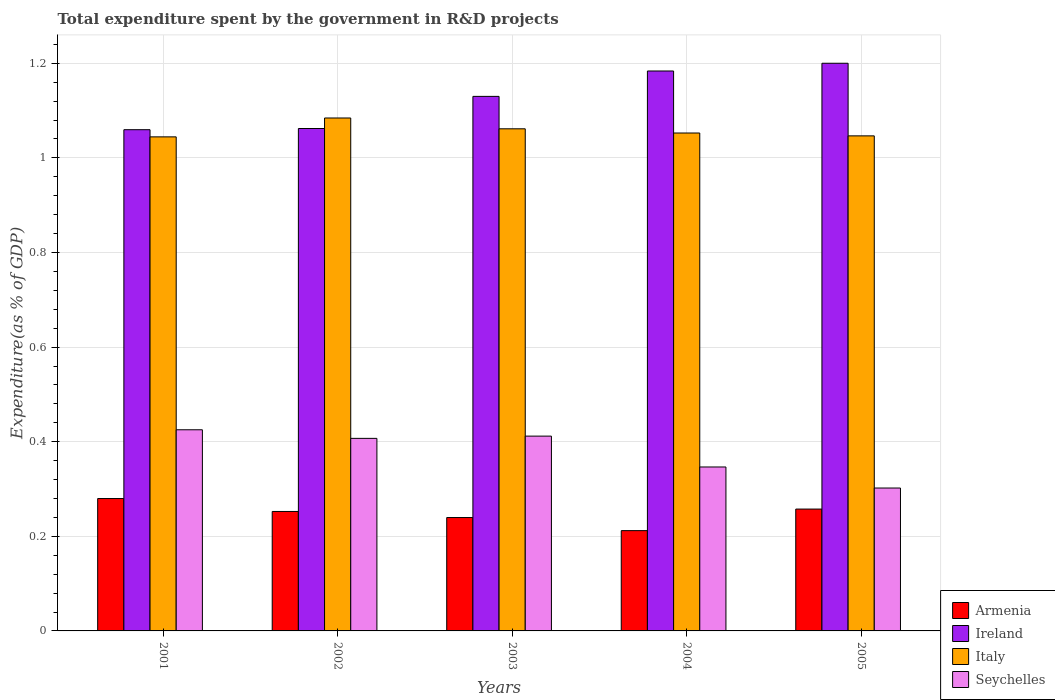How many different coloured bars are there?
Your answer should be very brief. 4. How many groups of bars are there?
Offer a very short reply. 5. Are the number of bars per tick equal to the number of legend labels?
Offer a terse response. Yes. Are the number of bars on each tick of the X-axis equal?
Ensure brevity in your answer.  Yes. How many bars are there on the 2nd tick from the right?
Your response must be concise. 4. What is the label of the 4th group of bars from the left?
Give a very brief answer. 2004. What is the total expenditure spent by the government in R&D projects in Italy in 2002?
Ensure brevity in your answer.  1.08. Across all years, what is the maximum total expenditure spent by the government in R&D projects in Armenia?
Ensure brevity in your answer.  0.28. Across all years, what is the minimum total expenditure spent by the government in R&D projects in Ireland?
Your answer should be compact. 1.06. In which year was the total expenditure spent by the government in R&D projects in Armenia minimum?
Keep it short and to the point. 2004. What is the total total expenditure spent by the government in R&D projects in Armenia in the graph?
Your answer should be compact. 1.24. What is the difference between the total expenditure spent by the government in R&D projects in Seychelles in 2004 and that in 2005?
Ensure brevity in your answer.  0.04. What is the difference between the total expenditure spent by the government in R&D projects in Ireland in 2005 and the total expenditure spent by the government in R&D projects in Seychelles in 2002?
Your answer should be compact. 0.79. What is the average total expenditure spent by the government in R&D projects in Seychelles per year?
Your response must be concise. 0.38. In the year 2001, what is the difference between the total expenditure spent by the government in R&D projects in Armenia and total expenditure spent by the government in R&D projects in Italy?
Provide a short and direct response. -0.76. In how many years, is the total expenditure spent by the government in R&D projects in Ireland greater than 0.16 %?
Your answer should be very brief. 5. What is the ratio of the total expenditure spent by the government in R&D projects in Italy in 2001 to that in 2005?
Ensure brevity in your answer.  1. Is the total expenditure spent by the government in R&D projects in Ireland in 2001 less than that in 2003?
Make the answer very short. Yes. Is the difference between the total expenditure spent by the government in R&D projects in Armenia in 2002 and 2004 greater than the difference between the total expenditure spent by the government in R&D projects in Italy in 2002 and 2004?
Make the answer very short. Yes. What is the difference between the highest and the second highest total expenditure spent by the government in R&D projects in Ireland?
Provide a succinct answer. 0.02. What is the difference between the highest and the lowest total expenditure spent by the government in R&D projects in Armenia?
Give a very brief answer. 0.07. What does the 1st bar from the left in 2001 represents?
Offer a very short reply. Armenia. What does the 4th bar from the right in 2005 represents?
Offer a very short reply. Armenia. How many bars are there?
Keep it short and to the point. 20. Are all the bars in the graph horizontal?
Your response must be concise. No. Are the values on the major ticks of Y-axis written in scientific E-notation?
Give a very brief answer. No. Does the graph contain any zero values?
Your answer should be compact. No. Does the graph contain grids?
Your answer should be very brief. Yes. How many legend labels are there?
Keep it short and to the point. 4. How are the legend labels stacked?
Ensure brevity in your answer.  Vertical. What is the title of the graph?
Provide a succinct answer. Total expenditure spent by the government in R&D projects. Does "Faeroe Islands" appear as one of the legend labels in the graph?
Your answer should be compact. No. What is the label or title of the Y-axis?
Your answer should be very brief. Expenditure(as % of GDP). What is the Expenditure(as % of GDP) of Armenia in 2001?
Give a very brief answer. 0.28. What is the Expenditure(as % of GDP) of Ireland in 2001?
Offer a terse response. 1.06. What is the Expenditure(as % of GDP) in Italy in 2001?
Keep it short and to the point. 1.04. What is the Expenditure(as % of GDP) in Seychelles in 2001?
Your response must be concise. 0.43. What is the Expenditure(as % of GDP) of Armenia in 2002?
Provide a succinct answer. 0.25. What is the Expenditure(as % of GDP) in Ireland in 2002?
Your answer should be very brief. 1.06. What is the Expenditure(as % of GDP) of Italy in 2002?
Give a very brief answer. 1.08. What is the Expenditure(as % of GDP) in Seychelles in 2002?
Make the answer very short. 0.41. What is the Expenditure(as % of GDP) of Armenia in 2003?
Ensure brevity in your answer.  0.24. What is the Expenditure(as % of GDP) of Ireland in 2003?
Your answer should be very brief. 1.13. What is the Expenditure(as % of GDP) of Italy in 2003?
Ensure brevity in your answer.  1.06. What is the Expenditure(as % of GDP) of Seychelles in 2003?
Make the answer very short. 0.41. What is the Expenditure(as % of GDP) of Armenia in 2004?
Provide a short and direct response. 0.21. What is the Expenditure(as % of GDP) in Ireland in 2004?
Give a very brief answer. 1.18. What is the Expenditure(as % of GDP) in Italy in 2004?
Give a very brief answer. 1.05. What is the Expenditure(as % of GDP) in Seychelles in 2004?
Make the answer very short. 0.35. What is the Expenditure(as % of GDP) of Armenia in 2005?
Your answer should be very brief. 0.26. What is the Expenditure(as % of GDP) in Ireland in 2005?
Provide a short and direct response. 1.2. What is the Expenditure(as % of GDP) of Italy in 2005?
Offer a very short reply. 1.05. What is the Expenditure(as % of GDP) of Seychelles in 2005?
Offer a terse response. 0.3. Across all years, what is the maximum Expenditure(as % of GDP) in Armenia?
Give a very brief answer. 0.28. Across all years, what is the maximum Expenditure(as % of GDP) of Ireland?
Your response must be concise. 1.2. Across all years, what is the maximum Expenditure(as % of GDP) in Italy?
Your response must be concise. 1.08. Across all years, what is the maximum Expenditure(as % of GDP) of Seychelles?
Provide a succinct answer. 0.43. Across all years, what is the minimum Expenditure(as % of GDP) of Armenia?
Offer a terse response. 0.21. Across all years, what is the minimum Expenditure(as % of GDP) in Ireland?
Your response must be concise. 1.06. Across all years, what is the minimum Expenditure(as % of GDP) of Italy?
Ensure brevity in your answer.  1.04. Across all years, what is the minimum Expenditure(as % of GDP) of Seychelles?
Your answer should be compact. 0.3. What is the total Expenditure(as % of GDP) in Armenia in the graph?
Your answer should be very brief. 1.24. What is the total Expenditure(as % of GDP) of Ireland in the graph?
Offer a terse response. 5.64. What is the total Expenditure(as % of GDP) of Italy in the graph?
Offer a very short reply. 5.29. What is the total Expenditure(as % of GDP) of Seychelles in the graph?
Give a very brief answer. 1.89. What is the difference between the Expenditure(as % of GDP) in Armenia in 2001 and that in 2002?
Your answer should be compact. 0.03. What is the difference between the Expenditure(as % of GDP) of Ireland in 2001 and that in 2002?
Provide a short and direct response. -0. What is the difference between the Expenditure(as % of GDP) in Italy in 2001 and that in 2002?
Provide a succinct answer. -0.04. What is the difference between the Expenditure(as % of GDP) of Seychelles in 2001 and that in 2002?
Provide a short and direct response. 0.02. What is the difference between the Expenditure(as % of GDP) in Armenia in 2001 and that in 2003?
Provide a succinct answer. 0.04. What is the difference between the Expenditure(as % of GDP) in Ireland in 2001 and that in 2003?
Keep it short and to the point. -0.07. What is the difference between the Expenditure(as % of GDP) of Italy in 2001 and that in 2003?
Make the answer very short. -0.02. What is the difference between the Expenditure(as % of GDP) of Seychelles in 2001 and that in 2003?
Provide a succinct answer. 0.01. What is the difference between the Expenditure(as % of GDP) in Armenia in 2001 and that in 2004?
Provide a short and direct response. 0.07. What is the difference between the Expenditure(as % of GDP) of Ireland in 2001 and that in 2004?
Make the answer very short. -0.12. What is the difference between the Expenditure(as % of GDP) in Italy in 2001 and that in 2004?
Make the answer very short. -0.01. What is the difference between the Expenditure(as % of GDP) in Seychelles in 2001 and that in 2004?
Your response must be concise. 0.08. What is the difference between the Expenditure(as % of GDP) in Armenia in 2001 and that in 2005?
Your answer should be compact. 0.02. What is the difference between the Expenditure(as % of GDP) of Ireland in 2001 and that in 2005?
Your response must be concise. -0.14. What is the difference between the Expenditure(as % of GDP) of Italy in 2001 and that in 2005?
Your answer should be compact. -0. What is the difference between the Expenditure(as % of GDP) in Seychelles in 2001 and that in 2005?
Your answer should be very brief. 0.12. What is the difference between the Expenditure(as % of GDP) of Armenia in 2002 and that in 2003?
Ensure brevity in your answer.  0.01. What is the difference between the Expenditure(as % of GDP) in Ireland in 2002 and that in 2003?
Make the answer very short. -0.07. What is the difference between the Expenditure(as % of GDP) in Italy in 2002 and that in 2003?
Your answer should be very brief. 0.02. What is the difference between the Expenditure(as % of GDP) of Seychelles in 2002 and that in 2003?
Provide a short and direct response. -0. What is the difference between the Expenditure(as % of GDP) of Armenia in 2002 and that in 2004?
Your response must be concise. 0.04. What is the difference between the Expenditure(as % of GDP) in Ireland in 2002 and that in 2004?
Your answer should be very brief. -0.12. What is the difference between the Expenditure(as % of GDP) of Italy in 2002 and that in 2004?
Your response must be concise. 0.03. What is the difference between the Expenditure(as % of GDP) of Seychelles in 2002 and that in 2004?
Provide a short and direct response. 0.06. What is the difference between the Expenditure(as % of GDP) in Armenia in 2002 and that in 2005?
Your answer should be very brief. -0.01. What is the difference between the Expenditure(as % of GDP) of Ireland in 2002 and that in 2005?
Offer a terse response. -0.14. What is the difference between the Expenditure(as % of GDP) in Italy in 2002 and that in 2005?
Your response must be concise. 0.04. What is the difference between the Expenditure(as % of GDP) of Seychelles in 2002 and that in 2005?
Provide a succinct answer. 0.1. What is the difference between the Expenditure(as % of GDP) of Armenia in 2003 and that in 2004?
Ensure brevity in your answer.  0.03. What is the difference between the Expenditure(as % of GDP) in Ireland in 2003 and that in 2004?
Your answer should be very brief. -0.05. What is the difference between the Expenditure(as % of GDP) of Italy in 2003 and that in 2004?
Provide a short and direct response. 0.01. What is the difference between the Expenditure(as % of GDP) of Seychelles in 2003 and that in 2004?
Offer a terse response. 0.07. What is the difference between the Expenditure(as % of GDP) of Armenia in 2003 and that in 2005?
Give a very brief answer. -0.02. What is the difference between the Expenditure(as % of GDP) in Ireland in 2003 and that in 2005?
Offer a terse response. -0.07. What is the difference between the Expenditure(as % of GDP) in Italy in 2003 and that in 2005?
Your answer should be compact. 0.01. What is the difference between the Expenditure(as % of GDP) of Seychelles in 2003 and that in 2005?
Make the answer very short. 0.11. What is the difference between the Expenditure(as % of GDP) of Armenia in 2004 and that in 2005?
Make the answer very short. -0.05. What is the difference between the Expenditure(as % of GDP) in Ireland in 2004 and that in 2005?
Offer a very short reply. -0.02. What is the difference between the Expenditure(as % of GDP) of Italy in 2004 and that in 2005?
Your answer should be compact. 0.01. What is the difference between the Expenditure(as % of GDP) in Seychelles in 2004 and that in 2005?
Offer a terse response. 0.04. What is the difference between the Expenditure(as % of GDP) in Armenia in 2001 and the Expenditure(as % of GDP) in Ireland in 2002?
Your response must be concise. -0.78. What is the difference between the Expenditure(as % of GDP) of Armenia in 2001 and the Expenditure(as % of GDP) of Italy in 2002?
Offer a terse response. -0.8. What is the difference between the Expenditure(as % of GDP) of Armenia in 2001 and the Expenditure(as % of GDP) of Seychelles in 2002?
Keep it short and to the point. -0.13. What is the difference between the Expenditure(as % of GDP) in Ireland in 2001 and the Expenditure(as % of GDP) in Italy in 2002?
Give a very brief answer. -0.02. What is the difference between the Expenditure(as % of GDP) of Ireland in 2001 and the Expenditure(as % of GDP) of Seychelles in 2002?
Ensure brevity in your answer.  0.65. What is the difference between the Expenditure(as % of GDP) of Italy in 2001 and the Expenditure(as % of GDP) of Seychelles in 2002?
Your response must be concise. 0.64. What is the difference between the Expenditure(as % of GDP) of Armenia in 2001 and the Expenditure(as % of GDP) of Ireland in 2003?
Keep it short and to the point. -0.85. What is the difference between the Expenditure(as % of GDP) in Armenia in 2001 and the Expenditure(as % of GDP) in Italy in 2003?
Offer a very short reply. -0.78. What is the difference between the Expenditure(as % of GDP) of Armenia in 2001 and the Expenditure(as % of GDP) of Seychelles in 2003?
Keep it short and to the point. -0.13. What is the difference between the Expenditure(as % of GDP) in Ireland in 2001 and the Expenditure(as % of GDP) in Italy in 2003?
Make the answer very short. -0. What is the difference between the Expenditure(as % of GDP) of Ireland in 2001 and the Expenditure(as % of GDP) of Seychelles in 2003?
Ensure brevity in your answer.  0.65. What is the difference between the Expenditure(as % of GDP) in Italy in 2001 and the Expenditure(as % of GDP) in Seychelles in 2003?
Ensure brevity in your answer.  0.63. What is the difference between the Expenditure(as % of GDP) of Armenia in 2001 and the Expenditure(as % of GDP) of Ireland in 2004?
Ensure brevity in your answer.  -0.9. What is the difference between the Expenditure(as % of GDP) in Armenia in 2001 and the Expenditure(as % of GDP) in Italy in 2004?
Keep it short and to the point. -0.77. What is the difference between the Expenditure(as % of GDP) in Armenia in 2001 and the Expenditure(as % of GDP) in Seychelles in 2004?
Provide a succinct answer. -0.07. What is the difference between the Expenditure(as % of GDP) of Ireland in 2001 and the Expenditure(as % of GDP) of Italy in 2004?
Give a very brief answer. 0.01. What is the difference between the Expenditure(as % of GDP) of Ireland in 2001 and the Expenditure(as % of GDP) of Seychelles in 2004?
Your answer should be compact. 0.71. What is the difference between the Expenditure(as % of GDP) of Italy in 2001 and the Expenditure(as % of GDP) of Seychelles in 2004?
Your response must be concise. 0.7. What is the difference between the Expenditure(as % of GDP) of Armenia in 2001 and the Expenditure(as % of GDP) of Ireland in 2005?
Keep it short and to the point. -0.92. What is the difference between the Expenditure(as % of GDP) in Armenia in 2001 and the Expenditure(as % of GDP) in Italy in 2005?
Make the answer very short. -0.77. What is the difference between the Expenditure(as % of GDP) of Armenia in 2001 and the Expenditure(as % of GDP) of Seychelles in 2005?
Offer a very short reply. -0.02. What is the difference between the Expenditure(as % of GDP) of Ireland in 2001 and the Expenditure(as % of GDP) of Italy in 2005?
Offer a terse response. 0.01. What is the difference between the Expenditure(as % of GDP) in Ireland in 2001 and the Expenditure(as % of GDP) in Seychelles in 2005?
Your answer should be very brief. 0.76. What is the difference between the Expenditure(as % of GDP) of Italy in 2001 and the Expenditure(as % of GDP) of Seychelles in 2005?
Keep it short and to the point. 0.74. What is the difference between the Expenditure(as % of GDP) in Armenia in 2002 and the Expenditure(as % of GDP) in Ireland in 2003?
Give a very brief answer. -0.88. What is the difference between the Expenditure(as % of GDP) of Armenia in 2002 and the Expenditure(as % of GDP) of Italy in 2003?
Your answer should be compact. -0.81. What is the difference between the Expenditure(as % of GDP) in Armenia in 2002 and the Expenditure(as % of GDP) in Seychelles in 2003?
Give a very brief answer. -0.16. What is the difference between the Expenditure(as % of GDP) of Ireland in 2002 and the Expenditure(as % of GDP) of Italy in 2003?
Your answer should be very brief. 0. What is the difference between the Expenditure(as % of GDP) in Ireland in 2002 and the Expenditure(as % of GDP) in Seychelles in 2003?
Ensure brevity in your answer.  0.65. What is the difference between the Expenditure(as % of GDP) of Italy in 2002 and the Expenditure(as % of GDP) of Seychelles in 2003?
Give a very brief answer. 0.67. What is the difference between the Expenditure(as % of GDP) of Armenia in 2002 and the Expenditure(as % of GDP) of Ireland in 2004?
Give a very brief answer. -0.93. What is the difference between the Expenditure(as % of GDP) of Armenia in 2002 and the Expenditure(as % of GDP) of Italy in 2004?
Make the answer very short. -0.8. What is the difference between the Expenditure(as % of GDP) in Armenia in 2002 and the Expenditure(as % of GDP) in Seychelles in 2004?
Ensure brevity in your answer.  -0.09. What is the difference between the Expenditure(as % of GDP) of Ireland in 2002 and the Expenditure(as % of GDP) of Italy in 2004?
Make the answer very short. 0.01. What is the difference between the Expenditure(as % of GDP) in Ireland in 2002 and the Expenditure(as % of GDP) in Seychelles in 2004?
Provide a short and direct response. 0.72. What is the difference between the Expenditure(as % of GDP) in Italy in 2002 and the Expenditure(as % of GDP) in Seychelles in 2004?
Keep it short and to the point. 0.74. What is the difference between the Expenditure(as % of GDP) of Armenia in 2002 and the Expenditure(as % of GDP) of Ireland in 2005?
Provide a succinct answer. -0.95. What is the difference between the Expenditure(as % of GDP) of Armenia in 2002 and the Expenditure(as % of GDP) of Italy in 2005?
Provide a short and direct response. -0.79. What is the difference between the Expenditure(as % of GDP) of Armenia in 2002 and the Expenditure(as % of GDP) of Seychelles in 2005?
Your answer should be very brief. -0.05. What is the difference between the Expenditure(as % of GDP) in Ireland in 2002 and the Expenditure(as % of GDP) in Italy in 2005?
Your response must be concise. 0.02. What is the difference between the Expenditure(as % of GDP) of Ireland in 2002 and the Expenditure(as % of GDP) of Seychelles in 2005?
Offer a terse response. 0.76. What is the difference between the Expenditure(as % of GDP) of Italy in 2002 and the Expenditure(as % of GDP) of Seychelles in 2005?
Make the answer very short. 0.78. What is the difference between the Expenditure(as % of GDP) of Armenia in 2003 and the Expenditure(as % of GDP) of Ireland in 2004?
Ensure brevity in your answer.  -0.94. What is the difference between the Expenditure(as % of GDP) in Armenia in 2003 and the Expenditure(as % of GDP) in Italy in 2004?
Ensure brevity in your answer.  -0.81. What is the difference between the Expenditure(as % of GDP) in Armenia in 2003 and the Expenditure(as % of GDP) in Seychelles in 2004?
Your answer should be compact. -0.11. What is the difference between the Expenditure(as % of GDP) of Ireland in 2003 and the Expenditure(as % of GDP) of Italy in 2004?
Offer a terse response. 0.08. What is the difference between the Expenditure(as % of GDP) of Ireland in 2003 and the Expenditure(as % of GDP) of Seychelles in 2004?
Ensure brevity in your answer.  0.78. What is the difference between the Expenditure(as % of GDP) in Italy in 2003 and the Expenditure(as % of GDP) in Seychelles in 2004?
Your answer should be compact. 0.71. What is the difference between the Expenditure(as % of GDP) of Armenia in 2003 and the Expenditure(as % of GDP) of Ireland in 2005?
Your answer should be very brief. -0.96. What is the difference between the Expenditure(as % of GDP) of Armenia in 2003 and the Expenditure(as % of GDP) of Italy in 2005?
Offer a very short reply. -0.81. What is the difference between the Expenditure(as % of GDP) in Armenia in 2003 and the Expenditure(as % of GDP) in Seychelles in 2005?
Make the answer very short. -0.06. What is the difference between the Expenditure(as % of GDP) in Ireland in 2003 and the Expenditure(as % of GDP) in Italy in 2005?
Your answer should be compact. 0.08. What is the difference between the Expenditure(as % of GDP) in Ireland in 2003 and the Expenditure(as % of GDP) in Seychelles in 2005?
Offer a very short reply. 0.83. What is the difference between the Expenditure(as % of GDP) in Italy in 2003 and the Expenditure(as % of GDP) in Seychelles in 2005?
Your answer should be very brief. 0.76. What is the difference between the Expenditure(as % of GDP) in Armenia in 2004 and the Expenditure(as % of GDP) in Ireland in 2005?
Make the answer very short. -0.99. What is the difference between the Expenditure(as % of GDP) in Armenia in 2004 and the Expenditure(as % of GDP) in Italy in 2005?
Make the answer very short. -0.83. What is the difference between the Expenditure(as % of GDP) in Armenia in 2004 and the Expenditure(as % of GDP) in Seychelles in 2005?
Provide a short and direct response. -0.09. What is the difference between the Expenditure(as % of GDP) of Ireland in 2004 and the Expenditure(as % of GDP) of Italy in 2005?
Your answer should be very brief. 0.14. What is the difference between the Expenditure(as % of GDP) of Ireland in 2004 and the Expenditure(as % of GDP) of Seychelles in 2005?
Your answer should be very brief. 0.88. What is the difference between the Expenditure(as % of GDP) in Italy in 2004 and the Expenditure(as % of GDP) in Seychelles in 2005?
Give a very brief answer. 0.75. What is the average Expenditure(as % of GDP) of Armenia per year?
Give a very brief answer. 0.25. What is the average Expenditure(as % of GDP) of Ireland per year?
Your response must be concise. 1.13. What is the average Expenditure(as % of GDP) of Italy per year?
Your response must be concise. 1.06. What is the average Expenditure(as % of GDP) of Seychelles per year?
Your answer should be very brief. 0.38. In the year 2001, what is the difference between the Expenditure(as % of GDP) of Armenia and Expenditure(as % of GDP) of Ireland?
Keep it short and to the point. -0.78. In the year 2001, what is the difference between the Expenditure(as % of GDP) of Armenia and Expenditure(as % of GDP) of Italy?
Provide a succinct answer. -0.76. In the year 2001, what is the difference between the Expenditure(as % of GDP) of Armenia and Expenditure(as % of GDP) of Seychelles?
Offer a terse response. -0.15. In the year 2001, what is the difference between the Expenditure(as % of GDP) in Ireland and Expenditure(as % of GDP) in Italy?
Provide a succinct answer. 0.02. In the year 2001, what is the difference between the Expenditure(as % of GDP) of Ireland and Expenditure(as % of GDP) of Seychelles?
Provide a succinct answer. 0.63. In the year 2001, what is the difference between the Expenditure(as % of GDP) of Italy and Expenditure(as % of GDP) of Seychelles?
Make the answer very short. 0.62. In the year 2002, what is the difference between the Expenditure(as % of GDP) in Armenia and Expenditure(as % of GDP) in Ireland?
Make the answer very short. -0.81. In the year 2002, what is the difference between the Expenditure(as % of GDP) in Armenia and Expenditure(as % of GDP) in Italy?
Offer a very short reply. -0.83. In the year 2002, what is the difference between the Expenditure(as % of GDP) of Armenia and Expenditure(as % of GDP) of Seychelles?
Give a very brief answer. -0.15. In the year 2002, what is the difference between the Expenditure(as % of GDP) in Ireland and Expenditure(as % of GDP) in Italy?
Your answer should be very brief. -0.02. In the year 2002, what is the difference between the Expenditure(as % of GDP) of Ireland and Expenditure(as % of GDP) of Seychelles?
Make the answer very short. 0.66. In the year 2002, what is the difference between the Expenditure(as % of GDP) in Italy and Expenditure(as % of GDP) in Seychelles?
Make the answer very short. 0.68. In the year 2003, what is the difference between the Expenditure(as % of GDP) in Armenia and Expenditure(as % of GDP) in Ireland?
Offer a terse response. -0.89. In the year 2003, what is the difference between the Expenditure(as % of GDP) in Armenia and Expenditure(as % of GDP) in Italy?
Your answer should be compact. -0.82. In the year 2003, what is the difference between the Expenditure(as % of GDP) of Armenia and Expenditure(as % of GDP) of Seychelles?
Give a very brief answer. -0.17. In the year 2003, what is the difference between the Expenditure(as % of GDP) of Ireland and Expenditure(as % of GDP) of Italy?
Your answer should be compact. 0.07. In the year 2003, what is the difference between the Expenditure(as % of GDP) in Ireland and Expenditure(as % of GDP) in Seychelles?
Offer a terse response. 0.72. In the year 2003, what is the difference between the Expenditure(as % of GDP) of Italy and Expenditure(as % of GDP) of Seychelles?
Offer a very short reply. 0.65. In the year 2004, what is the difference between the Expenditure(as % of GDP) in Armenia and Expenditure(as % of GDP) in Ireland?
Offer a very short reply. -0.97. In the year 2004, what is the difference between the Expenditure(as % of GDP) of Armenia and Expenditure(as % of GDP) of Italy?
Offer a terse response. -0.84. In the year 2004, what is the difference between the Expenditure(as % of GDP) of Armenia and Expenditure(as % of GDP) of Seychelles?
Provide a short and direct response. -0.13. In the year 2004, what is the difference between the Expenditure(as % of GDP) of Ireland and Expenditure(as % of GDP) of Italy?
Provide a short and direct response. 0.13. In the year 2004, what is the difference between the Expenditure(as % of GDP) in Ireland and Expenditure(as % of GDP) in Seychelles?
Ensure brevity in your answer.  0.84. In the year 2004, what is the difference between the Expenditure(as % of GDP) of Italy and Expenditure(as % of GDP) of Seychelles?
Your answer should be very brief. 0.71. In the year 2005, what is the difference between the Expenditure(as % of GDP) in Armenia and Expenditure(as % of GDP) in Ireland?
Your answer should be compact. -0.94. In the year 2005, what is the difference between the Expenditure(as % of GDP) in Armenia and Expenditure(as % of GDP) in Italy?
Your answer should be very brief. -0.79. In the year 2005, what is the difference between the Expenditure(as % of GDP) of Armenia and Expenditure(as % of GDP) of Seychelles?
Make the answer very short. -0.04. In the year 2005, what is the difference between the Expenditure(as % of GDP) of Ireland and Expenditure(as % of GDP) of Italy?
Offer a very short reply. 0.15. In the year 2005, what is the difference between the Expenditure(as % of GDP) of Ireland and Expenditure(as % of GDP) of Seychelles?
Your answer should be very brief. 0.9. In the year 2005, what is the difference between the Expenditure(as % of GDP) of Italy and Expenditure(as % of GDP) of Seychelles?
Your response must be concise. 0.74. What is the ratio of the Expenditure(as % of GDP) in Armenia in 2001 to that in 2002?
Your response must be concise. 1.11. What is the ratio of the Expenditure(as % of GDP) in Italy in 2001 to that in 2002?
Ensure brevity in your answer.  0.96. What is the ratio of the Expenditure(as % of GDP) in Seychelles in 2001 to that in 2002?
Keep it short and to the point. 1.04. What is the ratio of the Expenditure(as % of GDP) in Armenia in 2001 to that in 2003?
Give a very brief answer. 1.17. What is the ratio of the Expenditure(as % of GDP) of Ireland in 2001 to that in 2003?
Your answer should be compact. 0.94. What is the ratio of the Expenditure(as % of GDP) of Italy in 2001 to that in 2003?
Your response must be concise. 0.98. What is the ratio of the Expenditure(as % of GDP) of Seychelles in 2001 to that in 2003?
Your answer should be very brief. 1.03. What is the ratio of the Expenditure(as % of GDP) of Armenia in 2001 to that in 2004?
Ensure brevity in your answer.  1.32. What is the ratio of the Expenditure(as % of GDP) in Ireland in 2001 to that in 2004?
Ensure brevity in your answer.  0.9. What is the ratio of the Expenditure(as % of GDP) of Seychelles in 2001 to that in 2004?
Ensure brevity in your answer.  1.23. What is the ratio of the Expenditure(as % of GDP) in Armenia in 2001 to that in 2005?
Keep it short and to the point. 1.09. What is the ratio of the Expenditure(as % of GDP) in Ireland in 2001 to that in 2005?
Make the answer very short. 0.88. What is the ratio of the Expenditure(as % of GDP) of Seychelles in 2001 to that in 2005?
Offer a terse response. 1.41. What is the ratio of the Expenditure(as % of GDP) of Armenia in 2002 to that in 2003?
Keep it short and to the point. 1.05. What is the ratio of the Expenditure(as % of GDP) of Ireland in 2002 to that in 2003?
Your answer should be compact. 0.94. What is the ratio of the Expenditure(as % of GDP) of Italy in 2002 to that in 2003?
Your answer should be compact. 1.02. What is the ratio of the Expenditure(as % of GDP) in Seychelles in 2002 to that in 2003?
Offer a terse response. 0.99. What is the ratio of the Expenditure(as % of GDP) in Armenia in 2002 to that in 2004?
Your answer should be very brief. 1.19. What is the ratio of the Expenditure(as % of GDP) in Ireland in 2002 to that in 2004?
Ensure brevity in your answer.  0.9. What is the ratio of the Expenditure(as % of GDP) in Italy in 2002 to that in 2004?
Make the answer very short. 1.03. What is the ratio of the Expenditure(as % of GDP) of Seychelles in 2002 to that in 2004?
Offer a terse response. 1.17. What is the ratio of the Expenditure(as % of GDP) in Armenia in 2002 to that in 2005?
Offer a terse response. 0.98. What is the ratio of the Expenditure(as % of GDP) of Ireland in 2002 to that in 2005?
Make the answer very short. 0.89. What is the ratio of the Expenditure(as % of GDP) of Italy in 2002 to that in 2005?
Your answer should be very brief. 1.04. What is the ratio of the Expenditure(as % of GDP) in Seychelles in 2002 to that in 2005?
Provide a succinct answer. 1.35. What is the ratio of the Expenditure(as % of GDP) of Armenia in 2003 to that in 2004?
Your answer should be compact. 1.13. What is the ratio of the Expenditure(as % of GDP) of Ireland in 2003 to that in 2004?
Ensure brevity in your answer.  0.95. What is the ratio of the Expenditure(as % of GDP) in Italy in 2003 to that in 2004?
Your response must be concise. 1.01. What is the ratio of the Expenditure(as % of GDP) of Seychelles in 2003 to that in 2004?
Provide a succinct answer. 1.19. What is the ratio of the Expenditure(as % of GDP) in Armenia in 2003 to that in 2005?
Offer a very short reply. 0.93. What is the ratio of the Expenditure(as % of GDP) in Ireland in 2003 to that in 2005?
Your answer should be very brief. 0.94. What is the ratio of the Expenditure(as % of GDP) of Italy in 2003 to that in 2005?
Provide a succinct answer. 1.01. What is the ratio of the Expenditure(as % of GDP) in Seychelles in 2003 to that in 2005?
Your response must be concise. 1.36. What is the ratio of the Expenditure(as % of GDP) in Armenia in 2004 to that in 2005?
Your answer should be compact. 0.82. What is the ratio of the Expenditure(as % of GDP) in Ireland in 2004 to that in 2005?
Your answer should be compact. 0.99. What is the ratio of the Expenditure(as % of GDP) in Italy in 2004 to that in 2005?
Keep it short and to the point. 1.01. What is the ratio of the Expenditure(as % of GDP) in Seychelles in 2004 to that in 2005?
Make the answer very short. 1.15. What is the difference between the highest and the second highest Expenditure(as % of GDP) of Armenia?
Your response must be concise. 0.02. What is the difference between the highest and the second highest Expenditure(as % of GDP) in Ireland?
Keep it short and to the point. 0.02. What is the difference between the highest and the second highest Expenditure(as % of GDP) of Italy?
Offer a very short reply. 0.02. What is the difference between the highest and the second highest Expenditure(as % of GDP) of Seychelles?
Ensure brevity in your answer.  0.01. What is the difference between the highest and the lowest Expenditure(as % of GDP) in Armenia?
Provide a short and direct response. 0.07. What is the difference between the highest and the lowest Expenditure(as % of GDP) in Ireland?
Make the answer very short. 0.14. What is the difference between the highest and the lowest Expenditure(as % of GDP) in Italy?
Offer a very short reply. 0.04. What is the difference between the highest and the lowest Expenditure(as % of GDP) of Seychelles?
Ensure brevity in your answer.  0.12. 